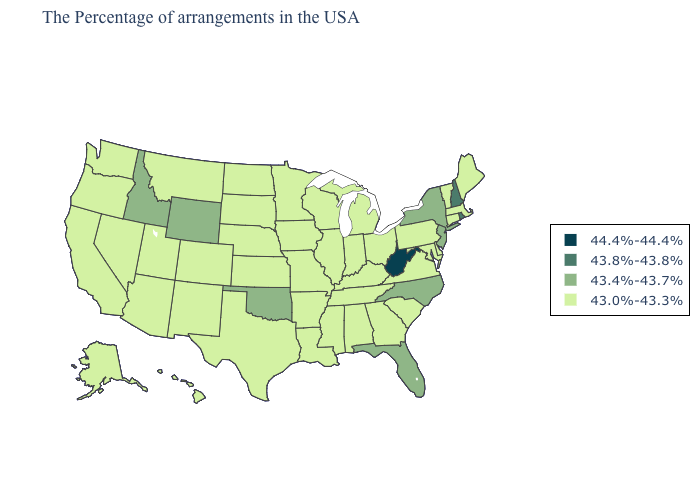Does New Jersey have the highest value in the Northeast?
Concise answer only. No. What is the value of Indiana?
Answer briefly. 43.0%-43.3%. Name the states that have a value in the range 44.4%-44.4%?
Quick response, please. West Virginia. Does Maryland have the highest value in the USA?
Concise answer only. No. What is the highest value in states that border Kentucky?
Keep it brief. 44.4%-44.4%. Name the states that have a value in the range 43.4%-43.7%?
Give a very brief answer. New York, New Jersey, North Carolina, Florida, Oklahoma, Wyoming, Idaho. What is the value of Missouri?
Give a very brief answer. 43.0%-43.3%. Does the map have missing data?
Keep it brief. No. Name the states that have a value in the range 43.0%-43.3%?
Short answer required. Maine, Massachusetts, Vermont, Connecticut, Delaware, Maryland, Pennsylvania, Virginia, South Carolina, Ohio, Georgia, Michigan, Kentucky, Indiana, Alabama, Tennessee, Wisconsin, Illinois, Mississippi, Louisiana, Missouri, Arkansas, Minnesota, Iowa, Kansas, Nebraska, Texas, South Dakota, North Dakota, Colorado, New Mexico, Utah, Montana, Arizona, Nevada, California, Washington, Oregon, Alaska, Hawaii. Does the map have missing data?
Write a very short answer. No. Does Michigan have the same value as North Carolina?
Give a very brief answer. No. What is the value of Oklahoma?
Keep it brief. 43.4%-43.7%. Which states have the lowest value in the USA?
Answer briefly. Maine, Massachusetts, Vermont, Connecticut, Delaware, Maryland, Pennsylvania, Virginia, South Carolina, Ohio, Georgia, Michigan, Kentucky, Indiana, Alabama, Tennessee, Wisconsin, Illinois, Mississippi, Louisiana, Missouri, Arkansas, Minnesota, Iowa, Kansas, Nebraska, Texas, South Dakota, North Dakota, Colorado, New Mexico, Utah, Montana, Arizona, Nevada, California, Washington, Oregon, Alaska, Hawaii. What is the highest value in the USA?
Write a very short answer. 44.4%-44.4%. 